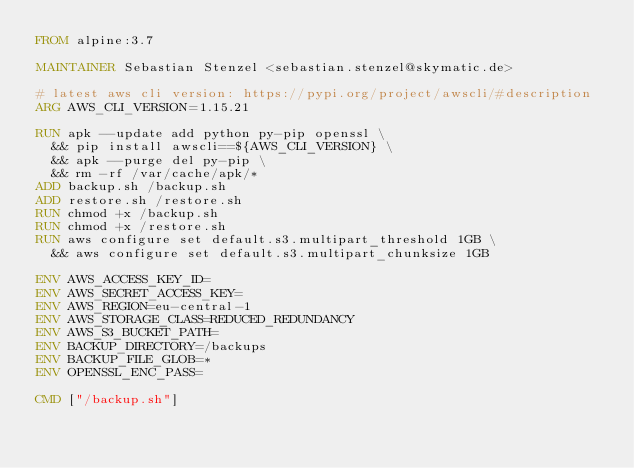<code> <loc_0><loc_0><loc_500><loc_500><_Dockerfile_>FROM alpine:3.7

MAINTAINER Sebastian Stenzel <sebastian.stenzel@skymatic.de>

# latest aws cli version: https://pypi.org/project/awscli/#description
ARG AWS_CLI_VERSION=1.15.21

RUN apk --update add python py-pip openssl \
  && pip install awscli==${AWS_CLI_VERSION} \
  && apk --purge del py-pip \
  && rm -rf /var/cache/apk/*
ADD backup.sh /backup.sh
ADD restore.sh /restore.sh
RUN chmod +x /backup.sh
RUN chmod +x /restore.sh
RUN aws configure set default.s3.multipart_threshold 1GB \
  && aws configure set default.s3.multipart_chunksize 1GB

ENV AWS_ACCESS_KEY_ID=
ENV AWS_SECRET_ACCESS_KEY=
ENV AWS_REGION=eu-central-1
ENV AWS_STORAGE_CLASS=REDUCED_REDUNDANCY
ENV AWS_S3_BUCKET_PATH=
ENV BACKUP_DIRECTORY=/backups
ENV BACKUP_FILE_GLOB=*
ENV OPENSSL_ENC_PASS=

CMD ["/backup.sh"]
</code> 